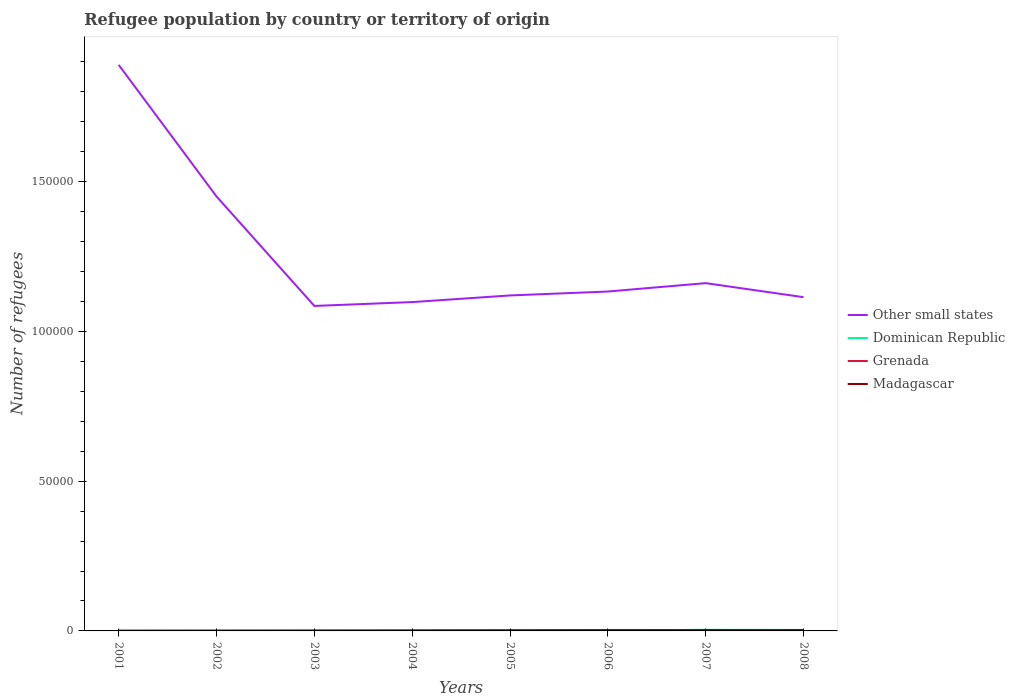How many different coloured lines are there?
Offer a terse response. 4. Is the number of lines equal to the number of legend labels?
Your response must be concise. Yes. Across all years, what is the maximum number of refugees in Other small states?
Ensure brevity in your answer.  1.08e+05. What is the total number of refugees in Dominican Republic in the graph?
Make the answer very short. -208. What is the difference between the highest and the second highest number of refugees in Other small states?
Keep it short and to the point. 8.05e+04. What is the difference between the highest and the lowest number of refugees in Dominican Republic?
Ensure brevity in your answer.  2. Is the number of refugees in Dominican Republic strictly greater than the number of refugees in Madagascar over the years?
Your response must be concise. No. What is the difference between two consecutive major ticks on the Y-axis?
Offer a very short reply. 5.00e+04. Where does the legend appear in the graph?
Offer a terse response. Center right. How are the legend labels stacked?
Ensure brevity in your answer.  Vertical. What is the title of the graph?
Ensure brevity in your answer.  Refugee population by country or territory of origin. Does "Cyprus" appear as one of the legend labels in the graph?
Your response must be concise. No. What is the label or title of the Y-axis?
Offer a terse response. Number of refugees. What is the Number of refugees of Other small states in 2001?
Your response must be concise. 1.89e+05. What is the Number of refugees of Grenada in 2001?
Offer a very short reply. 53. What is the Number of refugees of Madagascar in 2001?
Provide a succinct answer. 40. What is the Number of refugees in Other small states in 2002?
Offer a terse response. 1.45e+05. What is the Number of refugees in Dominican Republic in 2002?
Give a very brief answer. 83. What is the Number of refugees of Madagascar in 2002?
Make the answer very short. 53. What is the Number of refugees in Other small states in 2003?
Provide a succinct answer. 1.08e+05. What is the Number of refugees of Dominican Republic in 2003?
Offer a very short reply. 92. What is the Number of refugees of Other small states in 2004?
Provide a succinct answer. 1.10e+05. What is the Number of refugees in Dominican Republic in 2004?
Offer a terse response. 97. What is the Number of refugees of Madagascar in 2004?
Your response must be concise. 135. What is the Number of refugees of Other small states in 2005?
Make the answer very short. 1.12e+05. What is the Number of refugees in Dominican Republic in 2005?
Provide a short and direct response. 67. What is the Number of refugees of Grenada in 2005?
Ensure brevity in your answer.  152. What is the Number of refugees in Madagascar in 2005?
Ensure brevity in your answer.  203. What is the Number of refugees of Other small states in 2006?
Your answer should be very brief. 1.13e+05. What is the Number of refugees of Dominican Republic in 2006?
Keep it short and to the point. 150. What is the Number of refugees of Grenada in 2006?
Keep it short and to the point. 202. What is the Number of refugees of Madagascar in 2006?
Keep it short and to the point. 260. What is the Number of refugees of Other small states in 2007?
Offer a terse response. 1.16e+05. What is the Number of refugees of Dominican Republic in 2007?
Make the answer very short. 358. What is the Number of refugees in Grenada in 2007?
Your answer should be very brief. 297. What is the Number of refugees in Madagascar in 2007?
Provide a succinct answer. 284. What is the Number of refugees of Other small states in 2008?
Offer a very short reply. 1.11e+05. What is the Number of refugees in Dominican Republic in 2008?
Your response must be concise. 318. What is the Number of refugees of Grenada in 2008?
Your answer should be compact. 312. What is the Number of refugees in Madagascar in 2008?
Your answer should be very brief. 277. Across all years, what is the maximum Number of refugees of Other small states?
Your answer should be very brief. 1.89e+05. Across all years, what is the maximum Number of refugees of Dominican Republic?
Offer a very short reply. 358. Across all years, what is the maximum Number of refugees of Grenada?
Your answer should be compact. 312. Across all years, what is the maximum Number of refugees in Madagascar?
Offer a terse response. 284. Across all years, what is the minimum Number of refugees in Other small states?
Give a very brief answer. 1.08e+05. Across all years, what is the minimum Number of refugees of Dominican Republic?
Make the answer very short. 46. Across all years, what is the minimum Number of refugees of Grenada?
Give a very brief answer. 53. What is the total Number of refugees of Other small states in the graph?
Provide a short and direct response. 1.01e+06. What is the total Number of refugees in Dominican Republic in the graph?
Make the answer very short. 1211. What is the total Number of refugees in Grenada in the graph?
Provide a succinct answer. 1265. What is the total Number of refugees of Madagascar in the graph?
Your answer should be very brief. 1340. What is the difference between the Number of refugees of Other small states in 2001 and that in 2002?
Make the answer very short. 4.39e+04. What is the difference between the Number of refugees in Dominican Republic in 2001 and that in 2002?
Your response must be concise. -37. What is the difference between the Number of refugees in Other small states in 2001 and that in 2003?
Offer a very short reply. 8.05e+04. What is the difference between the Number of refugees of Dominican Republic in 2001 and that in 2003?
Give a very brief answer. -46. What is the difference between the Number of refugees in Madagascar in 2001 and that in 2003?
Offer a terse response. -48. What is the difference between the Number of refugees in Other small states in 2001 and that in 2004?
Make the answer very short. 7.92e+04. What is the difference between the Number of refugees of Dominican Republic in 2001 and that in 2004?
Give a very brief answer. -51. What is the difference between the Number of refugees of Grenada in 2001 and that in 2004?
Ensure brevity in your answer.  -46. What is the difference between the Number of refugees of Madagascar in 2001 and that in 2004?
Make the answer very short. -95. What is the difference between the Number of refugees of Other small states in 2001 and that in 2005?
Give a very brief answer. 7.70e+04. What is the difference between the Number of refugees of Dominican Republic in 2001 and that in 2005?
Give a very brief answer. -21. What is the difference between the Number of refugees in Grenada in 2001 and that in 2005?
Your response must be concise. -99. What is the difference between the Number of refugees of Madagascar in 2001 and that in 2005?
Offer a very short reply. -163. What is the difference between the Number of refugees of Other small states in 2001 and that in 2006?
Your response must be concise. 7.57e+04. What is the difference between the Number of refugees of Dominican Republic in 2001 and that in 2006?
Offer a very short reply. -104. What is the difference between the Number of refugees in Grenada in 2001 and that in 2006?
Offer a terse response. -149. What is the difference between the Number of refugees in Madagascar in 2001 and that in 2006?
Ensure brevity in your answer.  -220. What is the difference between the Number of refugees in Other small states in 2001 and that in 2007?
Provide a succinct answer. 7.29e+04. What is the difference between the Number of refugees in Dominican Republic in 2001 and that in 2007?
Your response must be concise. -312. What is the difference between the Number of refugees in Grenada in 2001 and that in 2007?
Keep it short and to the point. -244. What is the difference between the Number of refugees in Madagascar in 2001 and that in 2007?
Your answer should be very brief. -244. What is the difference between the Number of refugees in Other small states in 2001 and that in 2008?
Make the answer very short. 7.76e+04. What is the difference between the Number of refugees of Dominican Republic in 2001 and that in 2008?
Your response must be concise. -272. What is the difference between the Number of refugees in Grenada in 2001 and that in 2008?
Keep it short and to the point. -259. What is the difference between the Number of refugees of Madagascar in 2001 and that in 2008?
Make the answer very short. -237. What is the difference between the Number of refugees of Other small states in 2002 and that in 2003?
Give a very brief answer. 3.65e+04. What is the difference between the Number of refugees of Madagascar in 2002 and that in 2003?
Offer a very short reply. -35. What is the difference between the Number of refugees of Other small states in 2002 and that in 2004?
Give a very brief answer. 3.53e+04. What is the difference between the Number of refugees in Grenada in 2002 and that in 2004?
Your answer should be compact. -26. What is the difference between the Number of refugees in Madagascar in 2002 and that in 2004?
Give a very brief answer. -82. What is the difference between the Number of refugees of Other small states in 2002 and that in 2005?
Provide a short and direct response. 3.30e+04. What is the difference between the Number of refugees of Grenada in 2002 and that in 2005?
Provide a short and direct response. -79. What is the difference between the Number of refugees in Madagascar in 2002 and that in 2005?
Make the answer very short. -150. What is the difference between the Number of refugees of Other small states in 2002 and that in 2006?
Your response must be concise. 3.17e+04. What is the difference between the Number of refugees of Dominican Republic in 2002 and that in 2006?
Your response must be concise. -67. What is the difference between the Number of refugees in Grenada in 2002 and that in 2006?
Your response must be concise. -129. What is the difference between the Number of refugees in Madagascar in 2002 and that in 2006?
Your response must be concise. -207. What is the difference between the Number of refugees in Other small states in 2002 and that in 2007?
Make the answer very short. 2.89e+04. What is the difference between the Number of refugees in Dominican Republic in 2002 and that in 2007?
Your answer should be compact. -275. What is the difference between the Number of refugees in Grenada in 2002 and that in 2007?
Offer a terse response. -224. What is the difference between the Number of refugees of Madagascar in 2002 and that in 2007?
Your response must be concise. -231. What is the difference between the Number of refugees in Other small states in 2002 and that in 2008?
Your response must be concise. 3.36e+04. What is the difference between the Number of refugees in Dominican Republic in 2002 and that in 2008?
Keep it short and to the point. -235. What is the difference between the Number of refugees in Grenada in 2002 and that in 2008?
Make the answer very short. -239. What is the difference between the Number of refugees of Madagascar in 2002 and that in 2008?
Offer a terse response. -224. What is the difference between the Number of refugees in Other small states in 2003 and that in 2004?
Your answer should be very brief. -1286. What is the difference between the Number of refugees in Dominican Republic in 2003 and that in 2004?
Ensure brevity in your answer.  -5. What is the difference between the Number of refugees of Madagascar in 2003 and that in 2004?
Your response must be concise. -47. What is the difference between the Number of refugees of Other small states in 2003 and that in 2005?
Provide a short and direct response. -3506. What is the difference between the Number of refugees of Grenada in 2003 and that in 2005?
Offer a very short reply. -75. What is the difference between the Number of refugees of Madagascar in 2003 and that in 2005?
Your answer should be very brief. -115. What is the difference between the Number of refugees of Other small states in 2003 and that in 2006?
Provide a short and direct response. -4811. What is the difference between the Number of refugees in Dominican Republic in 2003 and that in 2006?
Provide a succinct answer. -58. What is the difference between the Number of refugees of Grenada in 2003 and that in 2006?
Keep it short and to the point. -125. What is the difference between the Number of refugees of Madagascar in 2003 and that in 2006?
Your answer should be very brief. -172. What is the difference between the Number of refugees in Other small states in 2003 and that in 2007?
Give a very brief answer. -7611. What is the difference between the Number of refugees in Dominican Republic in 2003 and that in 2007?
Provide a succinct answer. -266. What is the difference between the Number of refugees of Grenada in 2003 and that in 2007?
Ensure brevity in your answer.  -220. What is the difference between the Number of refugees of Madagascar in 2003 and that in 2007?
Your answer should be very brief. -196. What is the difference between the Number of refugees of Other small states in 2003 and that in 2008?
Your response must be concise. -2926. What is the difference between the Number of refugees in Dominican Republic in 2003 and that in 2008?
Provide a short and direct response. -226. What is the difference between the Number of refugees of Grenada in 2003 and that in 2008?
Keep it short and to the point. -235. What is the difference between the Number of refugees in Madagascar in 2003 and that in 2008?
Your response must be concise. -189. What is the difference between the Number of refugees in Other small states in 2004 and that in 2005?
Give a very brief answer. -2220. What is the difference between the Number of refugees in Grenada in 2004 and that in 2005?
Provide a short and direct response. -53. What is the difference between the Number of refugees in Madagascar in 2004 and that in 2005?
Your answer should be very brief. -68. What is the difference between the Number of refugees in Other small states in 2004 and that in 2006?
Your answer should be compact. -3525. What is the difference between the Number of refugees in Dominican Republic in 2004 and that in 2006?
Keep it short and to the point. -53. What is the difference between the Number of refugees of Grenada in 2004 and that in 2006?
Offer a terse response. -103. What is the difference between the Number of refugees in Madagascar in 2004 and that in 2006?
Make the answer very short. -125. What is the difference between the Number of refugees in Other small states in 2004 and that in 2007?
Offer a terse response. -6325. What is the difference between the Number of refugees in Dominican Republic in 2004 and that in 2007?
Make the answer very short. -261. What is the difference between the Number of refugees of Grenada in 2004 and that in 2007?
Provide a short and direct response. -198. What is the difference between the Number of refugees in Madagascar in 2004 and that in 2007?
Provide a succinct answer. -149. What is the difference between the Number of refugees in Other small states in 2004 and that in 2008?
Give a very brief answer. -1640. What is the difference between the Number of refugees of Dominican Republic in 2004 and that in 2008?
Ensure brevity in your answer.  -221. What is the difference between the Number of refugees in Grenada in 2004 and that in 2008?
Provide a succinct answer. -213. What is the difference between the Number of refugees in Madagascar in 2004 and that in 2008?
Ensure brevity in your answer.  -142. What is the difference between the Number of refugees in Other small states in 2005 and that in 2006?
Ensure brevity in your answer.  -1305. What is the difference between the Number of refugees of Dominican Republic in 2005 and that in 2006?
Ensure brevity in your answer.  -83. What is the difference between the Number of refugees in Madagascar in 2005 and that in 2006?
Your answer should be compact. -57. What is the difference between the Number of refugees of Other small states in 2005 and that in 2007?
Your answer should be very brief. -4105. What is the difference between the Number of refugees of Dominican Republic in 2005 and that in 2007?
Your answer should be compact. -291. What is the difference between the Number of refugees in Grenada in 2005 and that in 2007?
Provide a succinct answer. -145. What is the difference between the Number of refugees in Madagascar in 2005 and that in 2007?
Ensure brevity in your answer.  -81. What is the difference between the Number of refugees in Other small states in 2005 and that in 2008?
Make the answer very short. 580. What is the difference between the Number of refugees in Dominican Republic in 2005 and that in 2008?
Provide a short and direct response. -251. What is the difference between the Number of refugees of Grenada in 2005 and that in 2008?
Your response must be concise. -160. What is the difference between the Number of refugees in Madagascar in 2005 and that in 2008?
Your answer should be compact. -74. What is the difference between the Number of refugees in Other small states in 2006 and that in 2007?
Offer a terse response. -2800. What is the difference between the Number of refugees of Dominican Republic in 2006 and that in 2007?
Provide a succinct answer. -208. What is the difference between the Number of refugees of Grenada in 2006 and that in 2007?
Your response must be concise. -95. What is the difference between the Number of refugees of Madagascar in 2006 and that in 2007?
Your answer should be very brief. -24. What is the difference between the Number of refugees in Other small states in 2006 and that in 2008?
Make the answer very short. 1885. What is the difference between the Number of refugees of Dominican Republic in 2006 and that in 2008?
Make the answer very short. -168. What is the difference between the Number of refugees of Grenada in 2006 and that in 2008?
Offer a terse response. -110. What is the difference between the Number of refugees in Madagascar in 2006 and that in 2008?
Provide a short and direct response. -17. What is the difference between the Number of refugees in Other small states in 2007 and that in 2008?
Your response must be concise. 4685. What is the difference between the Number of refugees of Dominican Republic in 2007 and that in 2008?
Provide a succinct answer. 40. What is the difference between the Number of refugees of Madagascar in 2007 and that in 2008?
Ensure brevity in your answer.  7. What is the difference between the Number of refugees in Other small states in 2001 and the Number of refugees in Dominican Republic in 2002?
Offer a very short reply. 1.89e+05. What is the difference between the Number of refugees of Other small states in 2001 and the Number of refugees of Grenada in 2002?
Your answer should be very brief. 1.89e+05. What is the difference between the Number of refugees in Other small states in 2001 and the Number of refugees in Madagascar in 2002?
Your response must be concise. 1.89e+05. What is the difference between the Number of refugees in Dominican Republic in 2001 and the Number of refugees in Madagascar in 2002?
Make the answer very short. -7. What is the difference between the Number of refugees in Grenada in 2001 and the Number of refugees in Madagascar in 2002?
Provide a succinct answer. 0. What is the difference between the Number of refugees of Other small states in 2001 and the Number of refugees of Dominican Republic in 2003?
Keep it short and to the point. 1.89e+05. What is the difference between the Number of refugees of Other small states in 2001 and the Number of refugees of Grenada in 2003?
Keep it short and to the point. 1.89e+05. What is the difference between the Number of refugees in Other small states in 2001 and the Number of refugees in Madagascar in 2003?
Provide a succinct answer. 1.89e+05. What is the difference between the Number of refugees of Dominican Republic in 2001 and the Number of refugees of Grenada in 2003?
Offer a terse response. -31. What is the difference between the Number of refugees in Dominican Republic in 2001 and the Number of refugees in Madagascar in 2003?
Make the answer very short. -42. What is the difference between the Number of refugees of Grenada in 2001 and the Number of refugees of Madagascar in 2003?
Ensure brevity in your answer.  -35. What is the difference between the Number of refugees of Other small states in 2001 and the Number of refugees of Dominican Republic in 2004?
Provide a short and direct response. 1.89e+05. What is the difference between the Number of refugees of Other small states in 2001 and the Number of refugees of Grenada in 2004?
Provide a succinct answer. 1.89e+05. What is the difference between the Number of refugees in Other small states in 2001 and the Number of refugees in Madagascar in 2004?
Give a very brief answer. 1.89e+05. What is the difference between the Number of refugees of Dominican Republic in 2001 and the Number of refugees of Grenada in 2004?
Ensure brevity in your answer.  -53. What is the difference between the Number of refugees in Dominican Republic in 2001 and the Number of refugees in Madagascar in 2004?
Ensure brevity in your answer.  -89. What is the difference between the Number of refugees of Grenada in 2001 and the Number of refugees of Madagascar in 2004?
Keep it short and to the point. -82. What is the difference between the Number of refugees in Other small states in 2001 and the Number of refugees in Dominican Republic in 2005?
Offer a terse response. 1.89e+05. What is the difference between the Number of refugees in Other small states in 2001 and the Number of refugees in Grenada in 2005?
Your answer should be compact. 1.89e+05. What is the difference between the Number of refugees in Other small states in 2001 and the Number of refugees in Madagascar in 2005?
Offer a very short reply. 1.89e+05. What is the difference between the Number of refugees in Dominican Republic in 2001 and the Number of refugees in Grenada in 2005?
Keep it short and to the point. -106. What is the difference between the Number of refugees in Dominican Republic in 2001 and the Number of refugees in Madagascar in 2005?
Provide a succinct answer. -157. What is the difference between the Number of refugees of Grenada in 2001 and the Number of refugees of Madagascar in 2005?
Ensure brevity in your answer.  -150. What is the difference between the Number of refugees of Other small states in 2001 and the Number of refugees of Dominican Republic in 2006?
Your response must be concise. 1.89e+05. What is the difference between the Number of refugees of Other small states in 2001 and the Number of refugees of Grenada in 2006?
Provide a short and direct response. 1.89e+05. What is the difference between the Number of refugees in Other small states in 2001 and the Number of refugees in Madagascar in 2006?
Your answer should be compact. 1.89e+05. What is the difference between the Number of refugees in Dominican Republic in 2001 and the Number of refugees in Grenada in 2006?
Provide a succinct answer. -156. What is the difference between the Number of refugees in Dominican Republic in 2001 and the Number of refugees in Madagascar in 2006?
Give a very brief answer. -214. What is the difference between the Number of refugees of Grenada in 2001 and the Number of refugees of Madagascar in 2006?
Offer a very short reply. -207. What is the difference between the Number of refugees of Other small states in 2001 and the Number of refugees of Dominican Republic in 2007?
Give a very brief answer. 1.89e+05. What is the difference between the Number of refugees in Other small states in 2001 and the Number of refugees in Grenada in 2007?
Provide a succinct answer. 1.89e+05. What is the difference between the Number of refugees of Other small states in 2001 and the Number of refugees of Madagascar in 2007?
Make the answer very short. 1.89e+05. What is the difference between the Number of refugees in Dominican Republic in 2001 and the Number of refugees in Grenada in 2007?
Offer a terse response. -251. What is the difference between the Number of refugees of Dominican Republic in 2001 and the Number of refugees of Madagascar in 2007?
Provide a short and direct response. -238. What is the difference between the Number of refugees of Grenada in 2001 and the Number of refugees of Madagascar in 2007?
Ensure brevity in your answer.  -231. What is the difference between the Number of refugees of Other small states in 2001 and the Number of refugees of Dominican Republic in 2008?
Offer a very short reply. 1.89e+05. What is the difference between the Number of refugees of Other small states in 2001 and the Number of refugees of Grenada in 2008?
Your answer should be very brief. 1.89e+05. What is the difference between the Number of refugees of Other small states in 2001 and the Number of refugees of Madagascar in 2008?
Keep it short and to the point. 1.89e+05. What is the difference between the Number of refugees of Dominican Republic in 2001 and the Number of refugees of Grenada in 2008?
Provide a short and direct response. -266. What is the difference between the Number of refugees in Dominican Republic in 2001 and the Number of refugees in Madagascar in 2008?
Your answer should be compact. -231. What is the difference between the Number of refugees of Grenada in 2001 and the Number of refugees of Madagascar in 2008?
Provide a short and direct response. -224. What is the difference between the Number of refugees in Other small states in 2002 and the Number of refugees in Dominican Republic in 2003?
Your answer should be very brief. 1.45e+05. What is the difference between the Number of refugees in Other small states in 2002 and the Number of refugees in Grenada in 2003?
Your answer should be very brief. 1.45e+05. What is the difference between the Number of refugees of Other small states in 2002 and the Number of refugees of Madagascar in 2003?
Ensure brevity in your answer.  1.45e+05. What is the difference between the Number of refugees of Dominican Republic in 2002 and the Number of refugees of Grenada in 2003?
Your answer should be very brief. 6. What is the difference between the Number of refugees in Dominican Republic in 2002 and the Number of refugees in Madagascar in 2003?
Keep it short and to the point. -5. What is the difference between the Number of refugees in Other small states in 2002 and the Number of refugees in Dominican Republic in 2004?
Provide a succinct answer. 1.45e+05. What is the difference between the Number of refugees of Other small states in 2002 and the Number of refugees of Grenada in 2004?
Offer a very short reply. 1.45e+05. What is the difference between the Number of refugees of Other small states in 2002 and the Number of refugees of Madagascar in 2004?
Offer a terse response. 1.45e+05. What is the difference between the Number of refugees of Dominican Republic in 2002 and the Number of refugees of Madagascar in 2004?
Your answer should be compact. -52. What is the difference between the Number of refugees of Grenada in 2002 and the Number of refugees of Madagascar in 2004?
Keep it short and to the point. -62. What is the difference between the Number of refugees in Other small states in 2002 and the Number of refugees in Dominican Republic in 2005?
Offer a very short reply. 1.45e+05. What is the difference between the Number of refugees of Other small states in 2002 and the Number of refugees of Grenada in 2005?
Offer a very short reply. 1.45e+05. What is the difference between the Number of refugees of Other small states in 2002 and the Number of refugees of Madagascar in 2005?
Provide a succinct answer. 1.45e+05. What is the difference between the Number of refugees of Dominican Republic in 2002 and the Number of refugees of Grenada in 2005?
Provide a succinct answer. -69. What is the difference between the Number of refugees of Dominican Republic in 2002 and the Number of refugees of Madagascar in 2005?
Make the answer very short. -120. What is the difference between the Number of refugees in Grenada in 2002 and the Number of refugees in Madagascar in 2005?
Your response must be concise. -130. What is the difference between the Number of refugees in Other small states in 2002 and the Number of refugees in Dominican Republic in 2006?
Keep it short and to the point. 1.45e+05. What is the difference between the Number of refugees of Other small states in 2002 and the Number of refugees of Grenada in 2006?
Keep it short and to the point. 1.45e+05. What is the difference between the Number of refugees in Other small states in 2002 and the Number of refugees in Madagascar in 2006?
Provide a short and direct response. 1.45e+05. What is the difference between the Number of refugees of Dominican Republic in 2002 and the Number of refugees of Grenada in 2006?
Your answer should be very brief. -119. What is the difference between the Number of refugees of Dominican Republic in 2002 and the Number of refugees of Madagascar in 2006?
Give a very brief answer. -177. What is the difference between the Number of refugees in Grenada in 2002 and the Number of refugees in Madagascar in 2006?
Your answer should be compact. -187. What is the difference between the Number of refugees in Other small states in 2002 and the Number of refugees in Dominican Republic in 2007?
Your answer should be compact. 1.45e+05. What is the difference between the Number of refugees in Other small states in 2002 and the Number of refugees in Grenada in 2007?
Provide a succinct answer. 1.45e+05. What is the difference between the Number of refugees of Other small states in 2002 and the Number of refugees of Madagascar in 2007?
Your response must be concise. 1.45e+05. What is the difference between the Number of refugees of Dominican Republic in 2002 and the Number of refugees of Grenada in 2007?
Make the answer very short. -214. What is the difference between the Number of refugees of Dominican Republic in 2002 and the Number of refugees of Madagascar in 2007?
Keep it short and to the point. -201. What is the difference between the Number of refugees of Grenada in 2002 and the Number of refugees of Madagascar in 2007?
Your answer should be compact. -211. What is the difference between the Number of refugees in Other small states in 2002 and the Number of refugees in Dominican Republic in 2008?
Provide a succinct answer. 1.45e+05. What is the difference between the Number of refugees in Other small states in 2002 and the Number of refugees in Grenada in 2008?
Make the answer very short. 1.45e+05. What is the difference between the Number of refugees in Other small states in 2002 and the Number of refugees in Madagascar in 2008?
Provide a short and direct response. 1.45e+05. What is the difference between the Number of refugees in Dominican Republic in 2002 and the Number of refugees in Grenada in 2008?
Keep it short and to the point. -229. What is the difference between the Number of refugees of Dominican Republic in 2002 and the Number of refugees of Madagascar in 2008?
Your response must be concise. -194. What is the difference between the Number of refugees of Grenada in 2002 and the Number of refugees of Madagascar in 2008?
Offer a very short reply. -204. What is the difference between the Number of refugees of Other small states in 2003 and the Number of refugees of Dominican Republic in 2004?
Offer a very short reply. 1.08e+05. What is the difference between the Number of refugees of Other small states in 2003 and the Number of refugees of Grenada in 2004?
Ensure brevity in your answer.  1.08e+05. What is the difference between the Number of refugees of Other small states in 2003 and the Number of refugees of Madagascar in 2004?
Your response must be concise. 1.08e+05. What is the difference between the Number of refugees of Dominican Republic in 2003 and the Number of refugees of Madagascar in 2004?
Give a very brief answer. -43. What is the difference between the Number of refugees of Grenada in 2003 and the Number of refugees of Madagascar in 2004?
Your answer should be compact. -58. What is the difference between the Number of refugees of Other small states in 2003 and the Number of refugees of Dominican Republic in 2005?
Offer a terse response. 1.08e+05. What is the difference between the Number of refugees in Other small states in 2003 and the Number of refugees in Grenada in 2005?
Provide a short and direct response. 1.08e+05. What is the difference between the Number of refugees in Other small states in 2003 and the Number of refugees in Madagascar in 2005?
Provide a succinct answer. 1.08e+05. What is the difference between the Number of refugees in Dominican Republic in 2003 and the Number of refugees in Grenada in 2005?
Your response must be concise. -60. What is the difference between the Number of refugees in Dominican Republic in 2003 and the Number of refugees in Madagascar in 2005?
Your answer should be compact. -111. What is the difference between the Number of refugees in Grenada in 2003 and the Number of refugees in Madagascar in 2005?
Make the answer very short. -126. What is the difference between the Number of refugees of Other small states in 2003 and the Number of refugees of Dominican Republic in 2006?
Offer a very short reply. 1.08e+05. What is the difference between the Number of refugees in Other small states in 2003 and the Number of refugees in Grenada in 2006?
Offer a terse response. 1.08e+05. What is the difference between the Number of refugees of Other small states in 2003 and the Number of refugees of Madagascar in 2006?
Give a very brief answer. 1.08e+05. What is the difference between the Number of refugees in Dominican Republic in 2003 and the Number of refugees in Grenada in 2006?
Ensure brevity in your answer.  -110. What is the difference between the Number of refugees in Dominican Republic in 2003 and the Number of refugees in Madagascar in 2006?
Provide a short and direct response. -168. What is the difference between the Number of refugees of Grenada in 2003 and the Number of refugees of Madagascar in 2006?
Provide a short and direct response. -183. What is the difference between the Number of refugees in Other small states in 2003 and the Number of refugees in Dominican Republic in 2007?
Provide a succinct answer. 1.08e+05. What is the difference between the Number of refugees of Other small states in 2003 and the Number of refugees of Grenada in 2007?
Make the answer very short. 1.08e+05. What is the difference between the Number of refugees of Other small states in 2003 and the Number of refugees of Madagascar in 2007?
Give a very brief answer. 1.08e+05. What is the difference between the Number of refugees in Dominican Republic in 2003 and the Number of refugees in Grenada in 2007?
Ensure brevity in your answer.  -205. What is the difference between the Number of refugees in Dominican Republic in 2003 and the Number of refugees in Madagascar in 2007?
Offer a very short reply. -192. What is the difference between the Number of refugees of Grenada in 2003 and the Number of refugees of Madagascar in 2007?
Ensure brevity in your answer.  -207. What is the difference between the Number of refugees in Other small states in 2003 and the Number of refugees in Dominican Republic in 2008?
Provide a short and direct response. 1.08e+05. What is the difference between the Number of refugees in Other small states in 2003 and the Number of refugees in Grenada in 2008?
Ensure brevity in your answer.  1.08e+05. What is the difference between the Number of refugees of Other small states in 2003 and the Number of refugees of Madagascar in 2008?
Keep it short and to the point. 1.08e+05. What is the difference between the Number of refugees of Dominican Republic in 2003 and the Number of refugees of Grenada in 2008?
Give a very brief answer. -220. What is the difference between the Number of refugees in Dominican Republic in 2003 and the Number of refugees in Madagascar in 2008?
Your answer should be compact. -185. What is the difference between the Number of refugees of Grenada in 2003 and the Number of refugees of Madagascar in 2008?
Provide a short and direct response. -200. What is the difference between the Number of refugees in Other small states in 2004 and the Number of refugees in Dominican Republic in 2005?
Offer a terse response. 1.10e+05. What is the difference between the Number of refugees of Other small states in 2004 and the Number of refugees of Grenada in 2005?
Offer a very short reply. 1.10e+05. What is the difference between the Number of refugees in Other small states in 2004 and the Number of refugees in Madagascar in 2005?
Provide a short and direct response. 1.10e+05. What is the difference between the Number of refugees in Dominican Republic in 2004 and the Number of refugees in Grenada in 2005?
Your answer should be very brief. -55. What is the difference between the Number of refugees of Dominican Republic in 2004 and the Number of refugees of Madagascar in 2005?
Offer a terse response. -106. What is the difference between the Number of refugees of Grenada in 2004 and the Number of refugees of Madagascar in 2005?
Your response must be concise. -104. What is the difference between the Number of refugees of Other small states in 2004 and the Number of refugees of Dominican Republic in 2006?
Provide a short and direct response. 1.10e+05. What is the difference between the Number of refugees of Other small states in 2004 and the Number of refugees of Grenada in 2006?
Provide a succinct answer. 1.10e+05. What is the difference between the Number of refugees in Other small states in 2004 and the Number of refugees in Madagascar in 2006?
Offer a terse response. 1.10e+05. What is the difference between the Number of refugees of Dominican Republic in 2004 and the Number of refugees of Grenada in 2006?
Offer a very short reply. -105. What is the difference between the Number of refugees of Dominican Republic in 2004 and the Number of refugees of Madagascar in 2006?
Make the answer very short. -163. What is the difference between the Number of refugees in Grenada in 2004 and the Number of refugees in Madagascar in 2006?
Your answer should be very brief. -161. What is the difference between the Number of refugees in Other small states in 2004 and the Number of refugees in Dominican Republic in 2007?
Your answer should be compact. 1.09e+05. What is the difference between the Number of refugees of Other small states in 2004 and the Number of refugees of Grenada in 2007?
Your answer should be very brief. 1.09e+05. What is the difference between the Number of refugees in Other small states in 2004 and the Number of refugees in Madagascar in 2007?
Provide a short and direct response. 1.09e+05. What is the difference between the Number of refugees in Dominican Republic in 2004 and the Number of refugees in Grenada in 2007?
Offer a terse response. -200. What is the difference between the Number of refugees in Dominican Republic in 2004 and the Number of refugees in Madagascar in 2007?
Keep it short and to the point. -187. What is the difference between the Number of refugees in Grenada in 2004 and the Number of refugees in Madagascar in 2007?
Give a very brief answer. -185. What is the difference between the Number of refugees in Other small states in 2004 and the Number of refugees in Dominican Republic in 2008?
Make the answer very short. 1.09e+05. What is the difference between the Number of refugees in Other small states in 2004 and the Number of refugees in Grenada in 2008?
Your answer should be compact. 1.09e+05. What is the difference between the Number of refugees of Other small states in 2004 and the Number of refugees of Madagascar in 2008?
Keep it short and to the point. 1.10e+05. What is the difference between the Number of refugees in Dominican Republic in 2004 and the Number of refugees in Grenada in 2008?
Ensure brevity in your answer.  -215. What is the difference between the Number of refugees of Dominican Republic in 2004 and the Number of refugees of Madagascar in 2008?
Your response must be concise. -180. What is the difference between the Number of refugees of Grenada in 2004 and the Number of refugees of Madagascar in 2008?
Provide a short and direct response. -178. What is the difference between the Number of refugees of Other small states in 2005 and the Number of refugees of Dominican Republic in 2006?
Your response must be concise. 1.12e+05. What is the difference between the Number of refugees in Other small states in 2005 and the Number of refugees in Grenada in 2006?
Offer a very short reply. 1.12e+05. What is the difference between the Number of refugees of Other small states in 2005 and the Number of refugees of Madagascar in 2006?
Keep it short and to the point. 1.12e+05. What is the difference between the Number of refugees in Dominican Republic in 2005 and the Number of refugees in Grenada in 2006?
Your response must be concise. -135. What is the difference between the Number of refugees of Dominican Republic in 2005 and the Number of refugees of Madagascar in 2006?
Provide a short and direct response. -193. What is the difference between the Number of refugees in Grenada in 2005 and the Number of refugees in Madagascar in 2006?
Your answer should be very brief. -108. What is the difference between the Number of refugees in Other small states in 2005 and the Number of refugees in Dominican Republic in 2007?
Provide a short and direct response. 1.12e+05. What is the difference between the Number of refugees in Other small states in 2005 and the Number of refugees in Grenada in 2007?
Your answer should be compact. 1.12e+05. What is the difference between the Number of refugees in Other small states in 2005 and the Number of refugees in Madagascar in 2007?
Your response must be concise. 1.12e+05. What is the difference between the Number of refugees of Dominican Republic in 2005 and the Number of refugees of Grenada in 2007?
Offer a terse response. -230. What is the difference between the Number of refugees of Dominican Republic in 2005 and the Number of refugees of Madagascar in 2007?
Your answer should be very brief. -217. What is the difference between the Number of refugees in Grenada in 2005 and the Number of refugees in Madagascar in 2007?
Your answer should be very brief. -132. What is the difference between the Number of refugees of Other small states in 2005 and the Number of refugees of Dominican Republic in 2008?
Make the answer very short. 1.12e+05. What is the difference between the Number of refugees of Other small states in 2005 and the Number of refugees of Grenada in 2008?
Provide a succinct answer. 1.12e+05. What is the difference between the Number of refugees in Other small states in 2005 and the Number of refugees in Madagascar in 2008?
Provide a short and direct response. 1.12e+05. What is the difference between the Number of refugees in Dominican Republic in 2005 and the Number of refugees in Grenada in 2008?
Ensure brevity in your answer.  -245. What is the difference between the Number of refugees in Dominican Republic in 2005 and the Number of refugees in Madagascar in 2008?
Keep it short and to the point. -210. What is the difference between the Number of refugees of Grenada in 2005 and the Number of refugees of Madagascar in 2008?
Provide a short and direct response. -125. What is the difference between the Number of refugees in Other small states in 2006 and the Number of refugees in Dominican Republic in 2007?
Offer a terse response. 1.13e+05. What is the difference between the Number of refugees of Other small states in 2006 and the Number of refugees of Grenada in 2007?
Keep it short and to the point. 1.13e+05. What is the difference between the Number of refugees of Other small states in 2006 and the Number of refugees of Madagascar in 2007?
Give a very brief answer. 1.13e+05. What is the difference between the Number of refugees of Dominican Republic in 2006 and the Number of refugees of Grenada in 2007?
Your answer should be compact. -147. What is the difference between the Number of refugees of Dominican Republic in 2006 and the Number of refugees of Madagascar in 2007?
Provide a succinct answer. -134. What is the difference between the Number of refugees in Grenada in 2006 and the Number of refugees in Madagascar in 2007?
Make the answer very short. -82. What is the difference between the Number of refugees in Other small states in 2006 and the Number of refugees in Dominican Republic in 2008?
Provide a short and direct response. 1.13e+05. What is the difference between the Number of refugees in Other small states in 2006 and the Number of refugees in Grenada in 2008?
Your answer should be compact. 1.13e+05. What is the difference between the Number of refugees in Other small states in 2006 and the Number of refugees in Madagascar in 2008?
Keep it short and to the point. 1.13e+05. What is the difference between the Number of refugees of Dominican Republic in 2006 and the Number of refugees of Grenada in 2008?
Your response must be concise. -162. What is the difference between the Number of refugees in Dominican Republic in 2006 and the Number of refugees in Madagascar in 2008?
Your response must be concise. -127. What is the difference between the Number of refugees of Grenada in 2006 and the Number of refugees of Madagascar in 2008?
Your answer should be compact. -75. What is the difference between the Number of refugees in Other small states in 2007 and the Number of refugees in Dominican Republic in 2008?
Your response must be concise. 1.16e+05. What is the difference between the Number of refugees in Other small states in 2007 and the Number of refugees in Grenada in 2008?
Provide a succinct answer. 1.16e+05. What is the difference between the Number of refugees in Other small states in 2007 and the Number of refugees in Madagascar in 2008?
Offer a very short reply. 1.16e+05. What is the difference between the Number of refugees of Dominican Republic in 2007 and the Number of refugees of Grenada in 2008?
Make the answer very short. 46. What is the difference between the Number of refugees in Grenada in 2007 and the Number of refugees in Madagascar in 2008?
Offer a very short reply. 20. What is the average Number of refugees in Other small states per year?
Your answer should be compact. 1.26e+05. What is the average Number of refugees in Dominican Republic per year?
Keep it short and to the point. 151.38. What is the average Number of refugees in Grenada per year?
Make the answer very short. 158.12. What is the average Number of refugees in Madagascar per year?
Your answer should be very brief. 167.5. In the year 2001, what is the difference between the Number of refugees of Other small states and Number of refugees of Dominican Republic?
Provide a short and direct response. 1.89e+05. In the year 2001, what is the difference between the Number of refugees in Other small states and Number of refugees in Grenada?
Ensure brevity in your answer.  1.89e+05. In the year 2001, what is the difference between the Number of refugees in Other small states and Number of refugees in Madagascar?
Provide a short and direct response. 1.89e+05. In the year 2002, what is the difference between the Number of refugees in Other small states and Number of refugees in Dominican Republic?
Your response must be concise. 1.45e+05. In the year 2002, what is the difference between the Number of refugees in Other small states and Number of refugees in Grenada?
Your answer should be compact. 1.45e+05. In the year 2002, what is the difference between the Number of refugees in Other small states and Number of refugees in Madagascar?
Your answer should be very brief. 1.45e+05. In the year 2002, what is the difference between the Number of refugees of Dominican Republic and Number of refugees of Madagascar?
Give a very brief answer. 30. In the year 2003, what is the difference between the Number of refugees of Other small states and Number of refugees of Dominican Republic?
Offer a terse response. 1.08e+05. In the year 2003, what is the difference between the Number of refugees in Other small states and Number of refugees in Grenada?
Ensure brevity in your answer.  1.08e+05. In the year 2003, what is the difference between the Number of refugees of Other small states and Number of refugees of Madagascar?
Make the answer very short. 1.08e+05. In the year 2003, what is the difference between the Number of refugees of Dominican Republic and Number of refugees of Madagascar?
Offer a terse response. 4. In the year 2003, what is the difference between the Number of refugees of Grenada and Number of refugees of Madagascar?
Your response must be concise. -11. In the year 2004, what is the difference between the Number of refugees in Other small states and Number of refugees in Dominican Republic?
Keep it short and to the point. 1.10e+05. In the year 2004, what is the difference between the Number of refugees in Other small states and Number of refugees in Grenada?
Offer a very short reply. 1.10e+05. In the year 2004, what is the difference between the Number of refugees in Other small states and Number of refugees in Madagascar?
Offer a terse response. 1.10e+05. In the year 2004, what is the difference between the Number of refugees in Dominican Republic and Number of refugees in Madagascar?
Provide a short and direct response. -38. In the year 2004, what is the difference between the Number of refugees in Grenada and Number of refugees in Madagascar?
Offer a very short reply. -36. In the year 2005, what is the difference between the Number of refugees of Other small states and Number of refugees of Dominican Republic?
Keep it short and to the point. 1.12e+05. In the year 2005, what is the difference between the Number of refugees of Other small states and Number of refugees of Grenada?
Make the answer very short. 1.12e+05. In the year 2005, what is the difference between the Number of refugees in Other small states and Number of refugees in Madagascar?
Make the answer very short. 1.12e+05. In the year 2005, what is the difference between the Number of refugees of Dominican Republic and Number of refugees of Grenada?
Provide a short and direct response. -85. In the year 2005, what is the difference between the Number of refugees in Dominican Republic and Number of refugees in Madagascar?
Offer a very short reply. -136. In the year 2005, what is the difference between the Number of refugees of Grenada and Number of refugees of Madagascar?
Keep it short and to the point. -51. In the year 2006, what is the difference between the Number of refugees of Other small states and Number of refugees of Dominican Republic?
Provide a short and direct response. 1.13e+05. In the year 2006, what is the difference between the Number of refugees in Other small states and Number of refugees in Grenada?
Keep it short and to the point. 1.13e+05. In the year 2006, what is the difference between the Number of refugees in Other small states and Number of refugees in Madagascar?
Your answer should be very brief. 1.13e+05. In the year 2006, what is the difference between the Number of refugees in Dominican Republic and Number of refugees in Grenada?
Your answer should be compact. -52. In the year 2006, what is the difference between the Number of refugees in Dominican Republic and Number of refugees in Madagascar?
Keep it short and to the point. -110. In the year 2006, what is the difference between the Number of refugees of Grenada and Number of refugees of Madagascar?
Provide a short and direct response. -58. In the year 2007, what is the difference between the Number of refugees in Other small states and Number of refugees in Dominican Republic?
Give a very brief answer. 1.16e+05. In the year 2007, what is the difference between the Number of refugees of Other small states and Number of refugees of Grenada?
Offer a very short reply. 1.16e+05. In the year 2007, what is the difference between the Number of refugees in Other small states and Number of refugees in Madagascar?
Keep it short and to the point. 1.16e+05. In the year 2007, what is the difference between the Number of refugees in Dominican Republic and Number of refugees in Grenada?
Your answer should be very brief. 61. In the year 2007, what is the difference between the Number of refugees of Dominican Republic and Number of refugees of Madagascar?
Ensure brevity in your answer.  74. In the year 2007, what is the difference between the Number of refugees of Grenada and Number of refugees of Madagascar?
Your answer should be very brief. 13. In the year 2008, what is the difference between the Number of refugees in Other small states and Number of refugees in Dominican Republic?
Offer a terse response. 1.11e+05. In the year 2008, what is the difference between the Number of refugees of Other small states and Number of refugees of Grenada?
Make the answer very short. 1.11e+05. In the year 2008, what is the difference between the Number of refugees in Other small states and Number of refugees in Madagascar?
Provide a short and direct response. 1.11e+05. In the year 2008, what is the difference between the Number of refugees in Dominican Republic and Number of refugees in Madagascar?
Offer a very short reply. 41. What is the ratio of the Number of refugees in Other small states in 2001 to that in 2002?
Offer a terse response. 1.3. What is the ratio of the Number of refugees of Dominican Republic in 2001 to that in 2002?
Offer a terse response. 0.55. What is the ratio of the Number of refugees in Grenada in 2001 to that in 2002?
Ensure brevity in your answer.  0.73. What is the ratio of the Number of refugees of Madagascar in 2001 to that in 2002?
Your answer should be compact. 0.75. What is the ratio of the Number of refugees in Other small states in 2001 to that in 2003?
Provide a succinct answer. 1.74. What is the ratio of the Number of refugees of Dominican Republic in 2001 to that in 2003?
Provide a short and direct response. 0.5. What is the ratio of the Number of refugees of Grenada in 2001 to that in 2003?
Your answer should be very brief. 0.69. What is the ratio of the Number of refugees in Madagascar in 2001 to that in 2003?
Provide a short and direct response. 0.45. What is the ratio of the Number of refugees of Other small states in 2001 to that in 2004?
Make the answer very short. 1.72. What is the ratio of the Number of refugees of Dominican Republic in 2001 to that in 2004?
Offer a very short reply. 0.47. What is the ratio of the Number of refugees in Grenada in 2001 to that in 2004?
Keep it short and to the point. 0.54. What is the ratio of the Number of refugees of Madagascar in 2001 to that in 2004?
Ensure brevity in your answer.  0.3. What is the ratio of the Number of refugees of Other small states in 2001 to that in 2005?
Offer a terse response. 1.69. What is the ratio of the Number of refugees in Dominican Republic in 2001 to that in 2005?
Ensure brevity in your answer.  0.69. What is the ratio of the Number of refugees in Grenada in 2001 to that in 2005?
Make the answer very short. 0.35. What is the ratio of the Number of refugees of Madagascar in 2001 to that in 2005?
Your answer should be very brief. 0.2. What is the ratio of the Number of refugees in Other small states in 2001 to that in 2006?
Your response must be concise. 1.67. What is the ratio of the Number of refugees in Dominican Republic in 2001 to that in 2006?
Ensure brevity in your answer.  0.31. What is the ratio of the Number of refugees in Grenada in 2001 to that in 2006?
Make the answer very short. 0.26. What is the ratio of the Number of refugees in Madagascar in 2001 to that in 2006?
Provide a succinct answer. 0.15. What is the ratio of the Number of refugees in Other small states in 2001 to that in 2007?
Provide a short and direct response. 1.63. What is the ratio of the Number of refugees in Dominican Republic in 2001 to that in 2007?
Make the answer very short. 0.13. What is the ratio of the Number of refugees in Grenada in 2001 to that in 2007?
Your answer should be compact. 0.18. What is the ratio of the Number of refugees in Madagascar in 2001 to that in 2007?
Provide a succinct answer. 0.14. What is the ratio of the Number of refugees in Other small states in 2001 to that in 2008?
Your response must be concise. 1.7. What is the ratio of the Number of refugees of Dominican Republic in 2001 to that in 2008?
Offer a terse response. 0.14. What is the ratio of the Number of refugees of Grenada in 2001 to that in 2008?
Keep it short and to the point. 0.17. What is the ratio of the Number of refugees in Madagascar in 2001 to that in 2008?
Offer a terse response. 0.14. What is the ratio of the Number of refugees in Other small states in 2002 to that in 2003?
Provide a short and direct response. 1.34. What is the ratio of the Number of refugees of Dominican Republic in 2002 to that in 2003?
Provide a succinct answer. 0.9. What is the ratio of the Number of refugees of Grenada in 2002 to that in 2003?
Offer a terse response. 0.95. What is the ratio of the Number of refugees in Madagascar in 2002 to that in 2003?
Keep it short and to the point. 0.6. What is the ratio of the Number of refugees in Other small states in 2002 to that in 2004?
Offer a terse response. 1.32. What is the ratio of the Number of refugees in Dominican Republic in 2002 to that in 2004?
Provide a short and direct response. 0.86. What is the ratio of the Number of refugees of Grenada in 2002 to that in 2004?
Your answer should be very brief. 0.74. What is the ratio of the Number of refugees of Madagascar in 2002 to that in 2004?
Provide a short and direct response. 0.39. What is the ratio of the Number of refugees of Other small states in 2002 to that in 2005?
Ensure brevity in your answer.  1.29. What is the ratio of the Number of refugees of Dominican Republic in 2002 to that in 2005?
Your answer should be compact. 1.24. What is the ratio of the Number of refugees in Grenada in 2002 to that in 2005?
Provide a short and direct response. 0.48. What is the ratio of the Number of refugees in Madagascar in 2002 to that in 2005?
Provide a succinct answer. 0.26. What is the ratio of the Number of refugees in Other small states in 2002 to that in 2006?
Your answer should be very brief. 1.28. What is the ratio of the Number of refugees of Dominican Republic in 2002 to that in 2006?
Ensure brevity in your answer.  0.55. What is the ratio of the Number of refugees in Grenada in 2002 to that in 2006?
Offer a very short reply. 0.36. What is the ratio of the Number of refugees of Madagascar in 2002 to that in 2006?
Keep it short and to the point. 0.2. What is the ratio of the Number of refugees in Other small states in 2002 to that in 2007?
Keep it short and to the point. 1.25. What is the ratio of the Number of refugees in Dominican Republic in 2002 to that in 2007?
Your answer should be compact. 0.23. What is the ratio of the Number of refugees in Grenada in 2002 to that in 2007?
Your answer should be very brief. 0.25. What is the ratio of the Number of refugees in Madagascar in 2002 to that in 2007?
Your response must be concise. 0.19. What is the ratio of the Number of refugees of Other small states in 2002 to that in 2008?
Ensure brevity in your answer.  1.3. What is the ratio of the Number of refugees in Dominican Republic in 2002 to that in 2008?
Offer a very short reply. 0.26. What is the ratio of the Number of refugees of Grenada in 2002 to that in 2008?
Make the answer very short. 0.23. What is the ratio of the Number of refugees of Madagascar in 2002 to that in 2008?
Keep it short and to the point. 0.19. What is the ratio of the Number of refugees of Other small states in 2003 to that in 2004?
Your response must be concise. 0.99. What is the ratio of the Number of refugees of Dominican Republic in 2003 to that in 2004?
Keep it short and to the point. 0.95. What is the ratio of the Number of refugees of Madagascar in 2003 to that in 2004?
Give a very brief answer. 0.65. What is the ratio of the Number of refugees in Other small states in 2003 to that in 2005?
Your response must be concise. 0.97. What is the ratio of the Number of refugees in Dominican Republic in 2003 to that in 2005?
Offer a terse response. 1.37. What is the ratio of the Number of refugees of Grenada in 2003 to that in 2005?
Make the answer very short. 0.51. What is the ratio of the Number of refugees of Madagascar in 2003 to that in 2005?
Offer a terse response. 0.43. What is the ratio of the Number of refugees in Other small states in 2003 to that in 2006?
Make the answer very short. 0.96. What is the ratio of the Number of refugees of Dominican Republic in 2003 to that in 2006?
Offer a terse response. 0.61. What is the ratio of the Number of refugees in Grenada in 2003 to that in 2006?
Offer a very short reply. 0.38. What is the ratio of the Number of refugees in Madagascar in 2003 to that in 2006?
Make the answer very short. 0.34. What is the ratio of the Number of refugees of Other small states in 2003 to that in 2007?
Provide a succinct answer. 0.93. What is the ratio of the Number of refugees in Dominican Republic in 2003 to that in 2007?
Offer a terse response. 0.26. What is the ratio of the Number of refugees of Grenada in 2003 to that in 2007?
Give a very brief answer. 0.26. What is the ratio of the Number of refugees of Madagascar in 2003 to that in 2007?
Your answer should be compact. 0.31. What is the ratio of the Number of refugees of Other small states in 2003 to that in 2008?
Provide a short and direct response. 0.97. What is the ratio of the Number of refugees of Dominican Republic in 2003 to that in 2008?
Ensure brevity in your answer.  0.29. What is the ratio of the Number of refugees of Grenada in 2003 to that in 2008?
Your answer should be compact. 0.25. What is the ratio of the Number of refugees of Madagascar in 2003 to that in 2008?
Your response must be concise. 0.32. What is the ratio of the Number of refugees of Other small states in 2004 to that in 2005?
Give a very brief answer. 0.98. What is the ratio of the Number of refugees of Dominican Republic in 2004 to that in 2005?
Your answer should be very brief. 1.45. What is the ratio of the Number of refugees of Grenada in 2004 to that in 2005?
Make the answer very short. 0.65. What is the ratio of the Number of refugees in Madagascar in 2004 to that in 2005?
Your answer should be compact. 0.67. What is the ratio of the Number of refugees of Other small states in 2004 to that in 2006?
Give a very brief answer. 0.97. What is the ratio of the Number of refugees in Dominican Republic in 2004 to that in 2006?
Your response must be concise. 0.65. What is the ratio of the Number of refugees of Grenada in 2004 to that in 2006?
Provide a short and direct response. 0.49. What is the ratio of the Number of refugees in Madagascar in 2004 to that in 2006?
Keep it short and to the point. 0.52. What is the ratio of the Number of refugees in Other small states in 2004 to that in 2007?
Provide a short and direct response. 0.95. What is the ratio of the Number of refugees of Dominican Republic in 2004 to that in 2007?
Offer a terse response. 0.27. What is the ratio of the Number of refugees of Madagascar in 2004 to that in 2007?
Make the answer very short. 0.48. What is the ratio of the Number of refugees in Dominican Republic in 2004 to that in 2008?
Offer a terse response. 0.3. What is the ratio of the Number of refugees in Grenada in 2004 to that in 2008?
Keep it short and to the point. 0.32. What is the ratio of the Number of refugees in Madagascar in 2004 to that in 2008?
Make the answer very short. 0.49. What is the ratio of the Number of refugees in Dominican Republic in 2005 to that in 2006?
Your answer should be very brief. 0.45. What is the ratio of the Number of refugees in Grenada in 2005 to that in 2006?
Provide a short and direct response. 0.75. What is the ratio of the Number of refugees in Madagascar in 2005 to that in 2006?
Offer a very short reply. 0.78. What is the ratio of the Number of refugees of Other small states in 2005 to that in 2007?
Provide a short and direct response. 0.96. What is the ratio of the Number of refugees in Dominican Republic in 2005 to that in 2007?
Provide a short and direct response. 0.19. What is the ratio of the Number of refugees of Grenada in 2005 to that in 2007?
Make the answer very short. 0.51. What is the ratio of the Number of refugees of Madagascar in 2005 to that in 2007?
Your response must be concise. 0.71. What is the ratio of the Number of refugees of Other small states in 2005 to that in 2008?
Provide a succinct answer. 1.01. What is the ratio of the Number of refugees in Dominican Republic in 2005 to that in 2008?
Your response must be concise. 0.21. What is the ratio of the Number of refugees of Grenada in 2005 to that in 2008?
Offer a very short reply. 0.49. What is the ratio of the Number of refugees of Madagascar in 2005 to that in 2008?
Your response must be concise. 0.73. What is the ratio of the Number of refugees in Other small states in 2006 to that in 2007?
Your response must be concise. 0.98. What is the ratio of the Number of refugees in Dominican Republic in 2006 to that in 2007?
Provide a short and direct response. 0.42. What is the ratio of the Number of refugees of Grenada in 2006 to that in 2007?
Make the answer very short. 0.68. What is the ratio of the Number of refugees of Madagascar in 2006 to that in 2007?
Your answer should be compact. 0.92. What is the ratio of the Number of refugees of Other small states in 2006 to that in 2008?
Give a very brief answer. 1.02. What is the ratio of the Number of refugees of Dominican Republic in 2006 to that in 2008?
Provide a short and direct response. 0.47. What is the ratio of the Number of refugees in Grenada in 2006 to that in 2008?
Offer a very short reply. 0.65. What is the ratio of the Number of refugees of Madagascar in 2006 to that in 2008?
Give a very brief answer. 0.94. What is the ratio of the Number of refugees of Other small states in 2007 to that in 2008?
Ensure brevity in your answer.  1.04. What is the ratio of the Number of refugees in Dominican Republic in 2007 to that in 2008?
Provide a short and direct response. 1.13. What is the ratio of the Number of refugees in Grenada in 2007 to that in 2008?
Your answer should be very brief. 0.95. What is the ratio of the Number of refugees of Madagascar in 2007 to that in 2008?
Offer a terse response. 1.03. What is the difference between the highest and the second highest Number of refugees of Other small states?
Make the answer very short. 4.39e+04. What is the difference between the highest and the second highest Number of refugees of Dominican Republic?
Keep it short and to the point. 40. What is the difference between the highest and the second highest Number of refugees in Grenada?
Your answer should be compact. 15. What is the difference between the highest and the lowest Number of refugees of Other small states?
Give a very brief answer. 8.05e+04. What is the difference between the highest and the lowest Number of refugees of Dominican Republic?
Your answer should be very brief. 312. What is the difference between the highest and the lowest Number of refugees in Grenada?
Provide a short and direct response. 259. What is the difference between the highest and the lowest Number of refugees of Madagascar?
Provide a short and direct response. 244. 